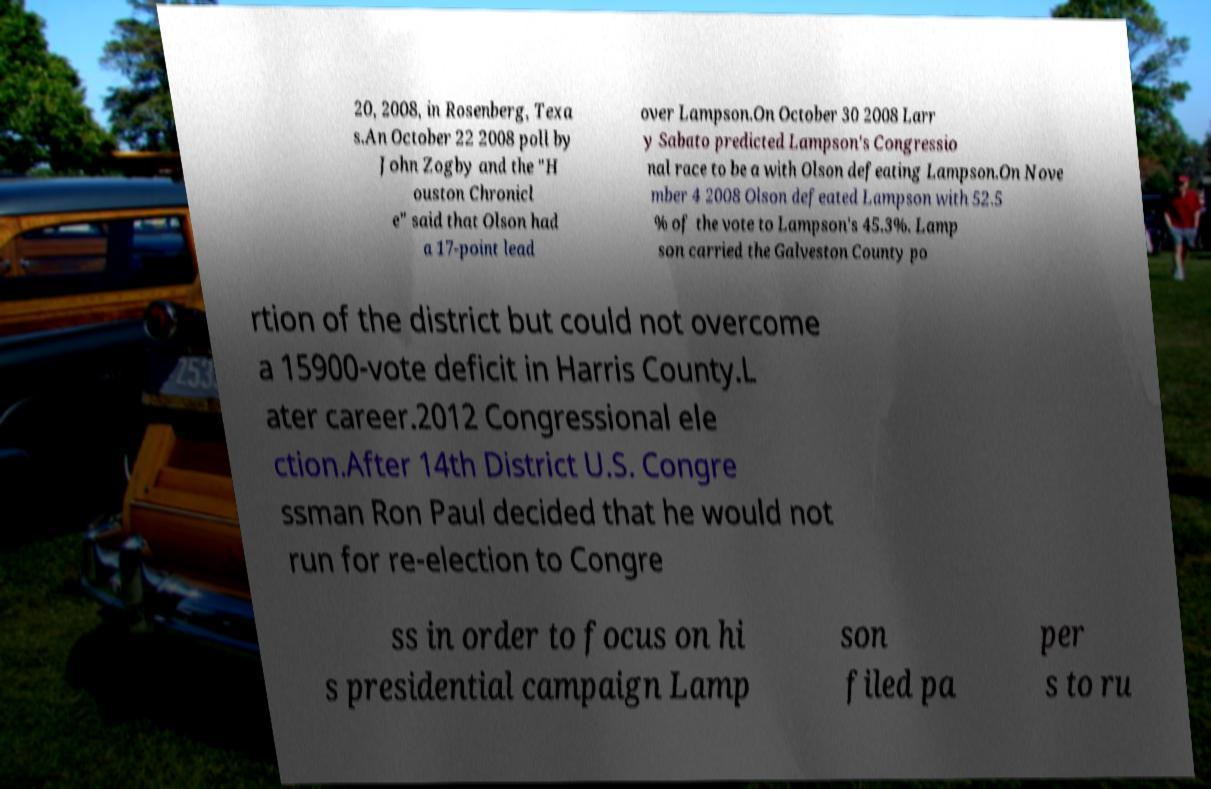Please identify and transcribe the text found in this image. 20, 2008, in Rosenberg, Texa s.An October 22 2008 poll by John Zogby and the "H ouston Chronicl e" said that Olson had a 17-point lead over Lampson.On October 30 2008 Larr y Sabato predicted Lampson's Congressio nal race to be a with Olson defeating Lampson.On Nove mber 4 2008 Olson defeated Lampson with 52.5 % of the vote to Lampson's 45.3%. Lamp son carried the Galveston County po rtion of the district but could not overcome a 15900-vote deficit in Harris County.L ater career.2012 Congressional ele ction.After 14th District U.S. Congre ssman Ron Paul decided that he would not run for re-election to Congre ss in order to focus on hi s presidential campaign Lamp son filed pa per s to ru 